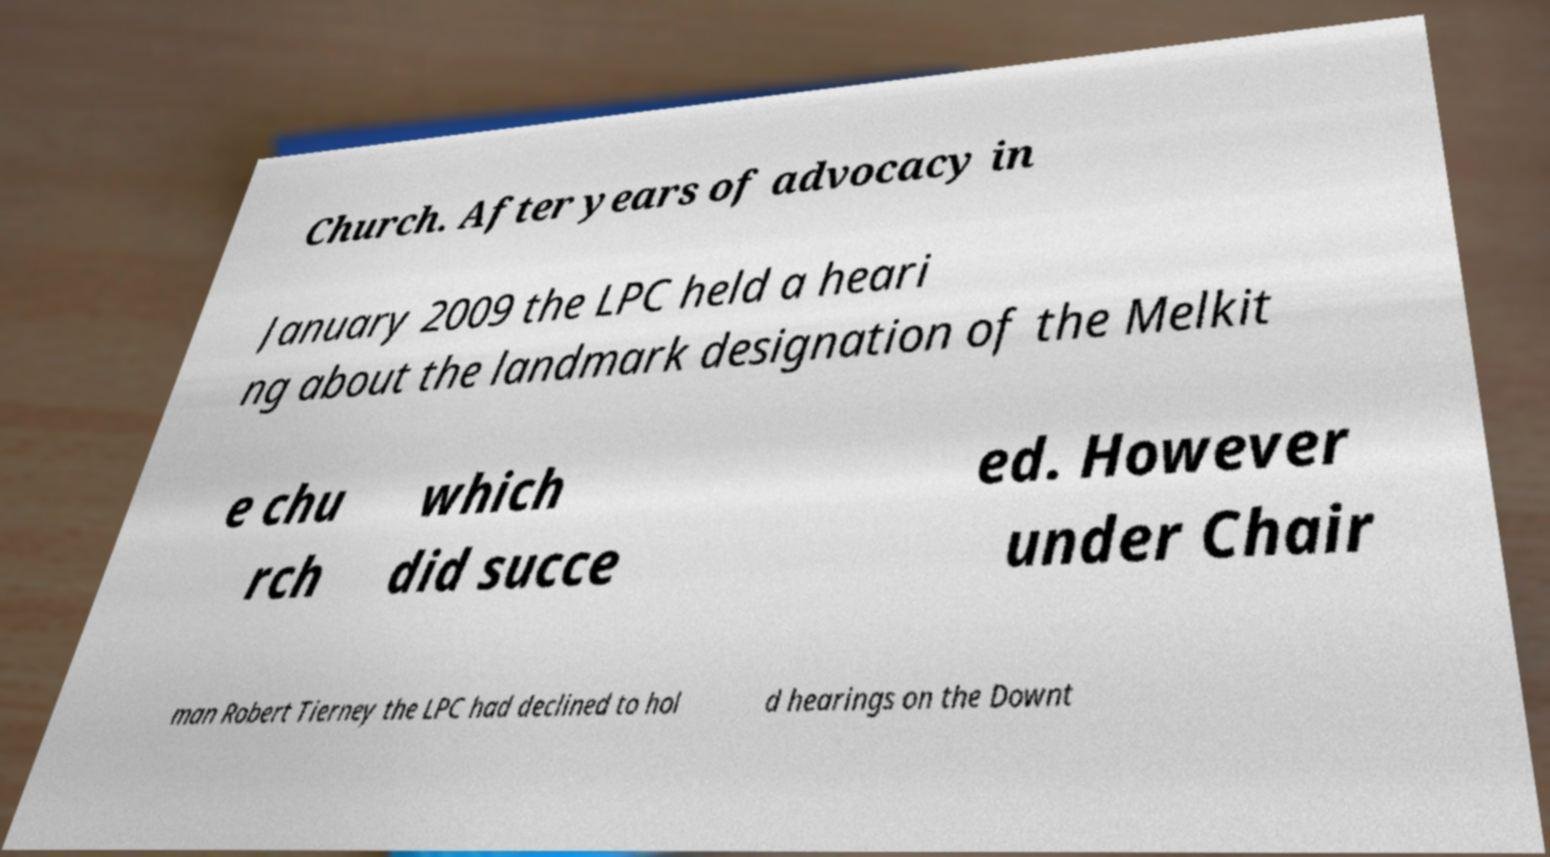Please identify and transcribe the text found in this image. Church. After years of advocacy in January 2009 the LPC held a heari ng about the landmark designation of the Melkit e chu rch which did succe ed. However under Chair man Robert Tierney the LPC had declined to hol d hearings on the Downt 